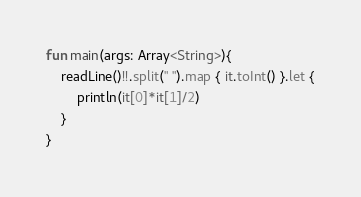<code> <loc_0><loc_0><loc_500><loc_500><_Kotlin_>fun main(args: Array<String>){
    readLine()!!.split(" ").map { it.toInt() }.let {
        println(it[0]*it[1]/2)
    }
}</code> 